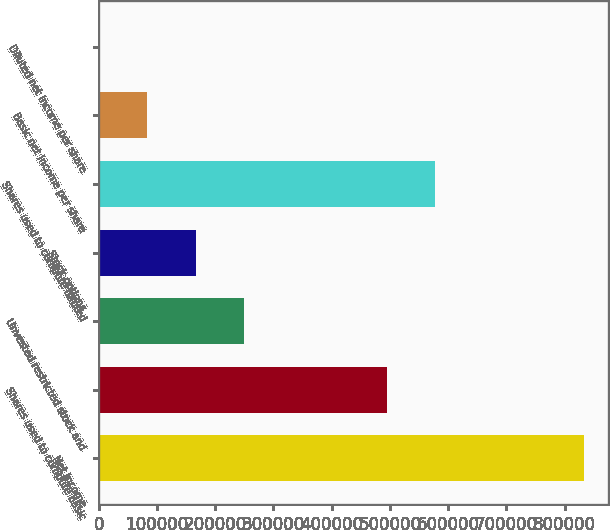Convert chart. <chart><loc_0><loc_0><loc_500><loc_500><bar_chart><fcel>Net income<fcel>Shares used to compute basic<fcel>Unvested restricted stock and<fcel>Stock options<fcel>Shares used to compute diluted<fcel>Basic net income per share<fcel>Diluted net income per share<nl><fcel>832775<fcel>494731<fcel>249834<fcel>166556<fcel>578008<fcel>83279<fcel>1.66<nl></chart> 